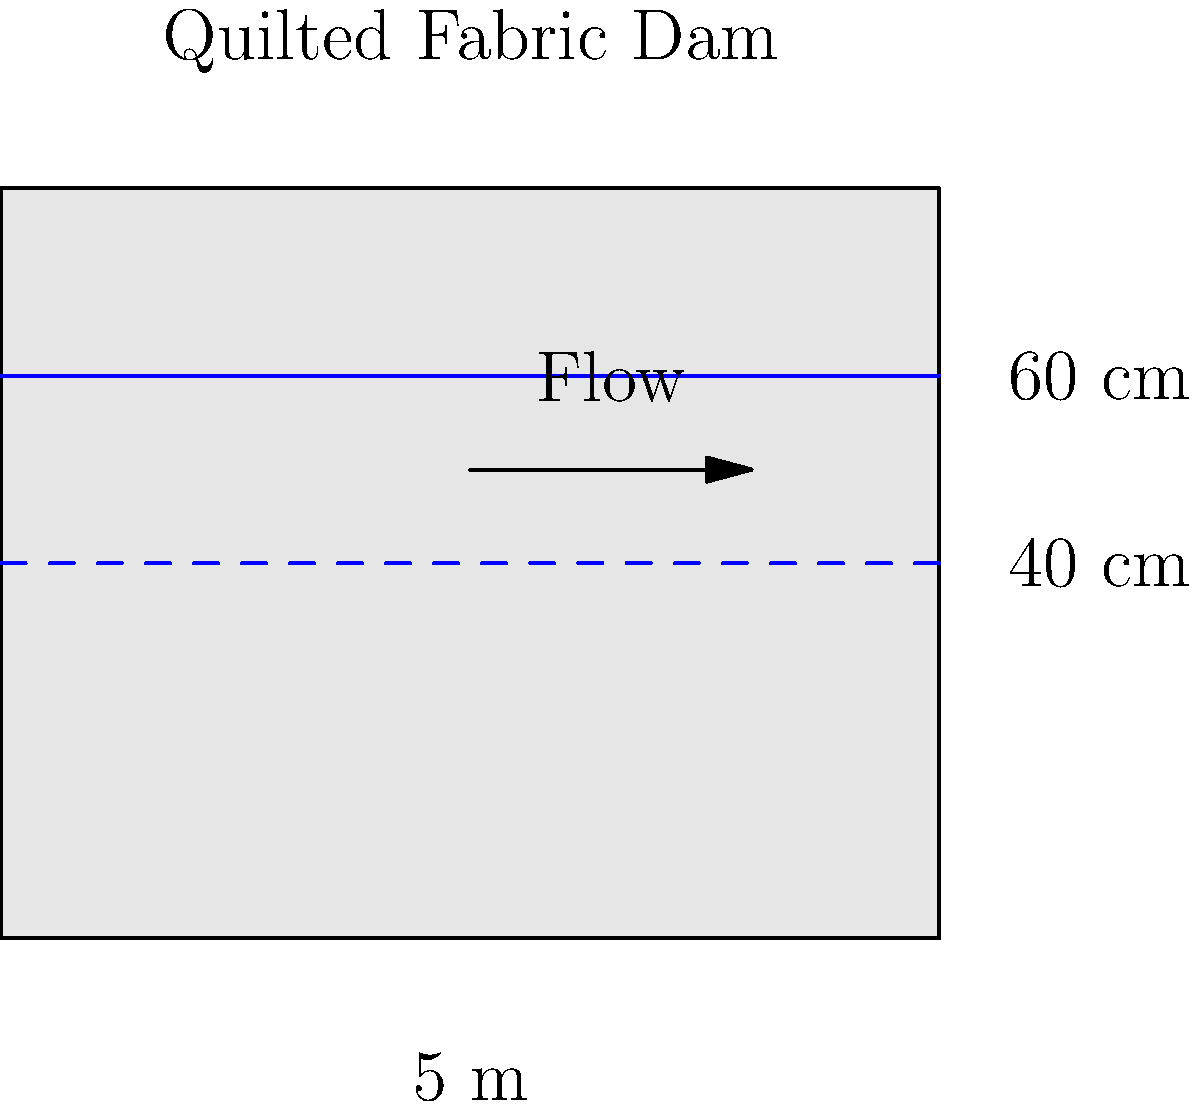As a quilter with experience in fabric structures, you've been asked to consult on a unique civil engineering project: a quilted fabric dam. The dam is 5 meters wide and uses a special waterproof quilted fabric. When the water level is at 60 cm, the flow rate through the dam is 0.2 m³/s. Assuming the flow rate is proportional to the square of the water depth, what would be the flow rate when the water level drops to 40 cm? Let's approach this step-by-step, using our quilting knowledge to understand the fabric's behavior:

1) We know that the flow rate (Q) is proportional to the square of the water depth (h). We can express this as:

   $Q \propto h^2$

2) Let's call the constant of proportionality k. So our equation becomes:

   $Q = kh^2$

3) We're given two scenarios:
   Scenario 1: h₁ = 60 cm, Q₁ = 0.2 m³/s
   Scenario 2: h₂ = 40 cm, Q₂ = unknown

4) Using the first scenario, we can find k:

   $0.2 = k(0.6)^2$
   $k = 0.2 / 0.36 = 0.5556$

5) Now we can use this k value in the second scenario:

   $Q₂ = 0.5556(0.4)^2$

6) Calculating:
   $Q₂ = 0.5556 * 0.16 = 0.08889 \text{ m³/s}$

7) Rounding to two decimal places:
   $Q₂ ≈ 0.09 \text{ m³/s}$

This result shows how the tighter weave of the quilted fabric at lower water levels reduces the flow rate, similar to how a dense quilt pattern can affect water absorption in fabric.
Answer: 0.09 m³/s 